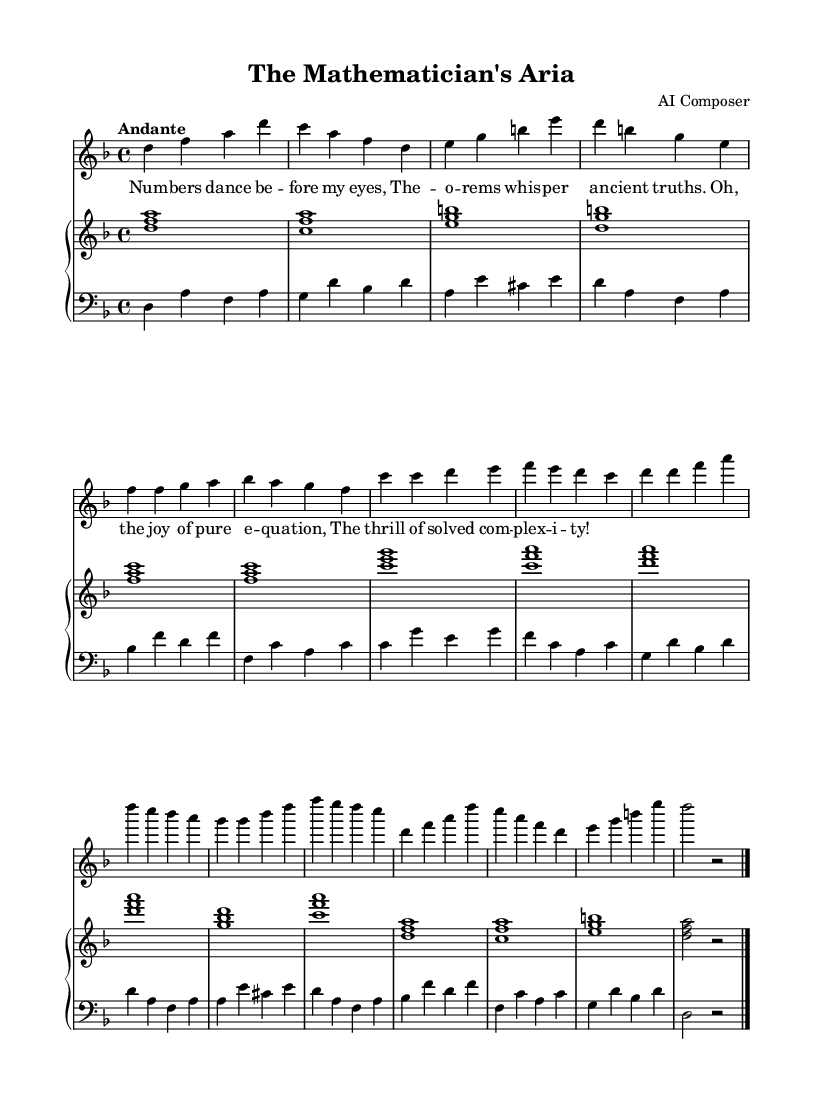What is the key signature of this music? The key signature in the sheet music indicates the key of D minor, which contains one flat, B flat. This can be determined by looking at the key signature at the beginning of the staff.
Answer: D minor What is the time signature of this music? The time signature displayed on the music sheet is 4/4, visible in the first measure. This indicates there are four beats in each measure, and the quarter note receives one beat.
Answer: 4/4 What is the tempo marking of this piece? The tempo marking "Andante" is indicated at the beginning of the piece, which suggests a moderate pace. This can be seen just after the time signature.
Answer: Andante How many measures are in the introductory section? Counting the measures in the introductory section from the start, there are four measures before the first verse begins. Each measure can be visually identified by the vertical lines separating them.
Answer: 4 What type of aria is primarily represented in this piece? This piece is a soprano aria, as indicated by the use of a soprano vocal part in the score. The clarity of the soprano staff and lyrics confirms its designation as an aria for a single voice.
Answer: Soprano aria Which musical section contains the repeated melodic phrases? The chorus section contains repeated musical phrases, as observable from the repetitive melody patterns in the specified measures. The structure shows clear phrases that recur.
Answer: Chorus What is the purpose of the coda in this piece? The coda serves to conclude the piece, bringing a resolution to the musical material presented earlier. This section, indicated at the end, sums up the themes and provides closure.
Answer: Conclusion 